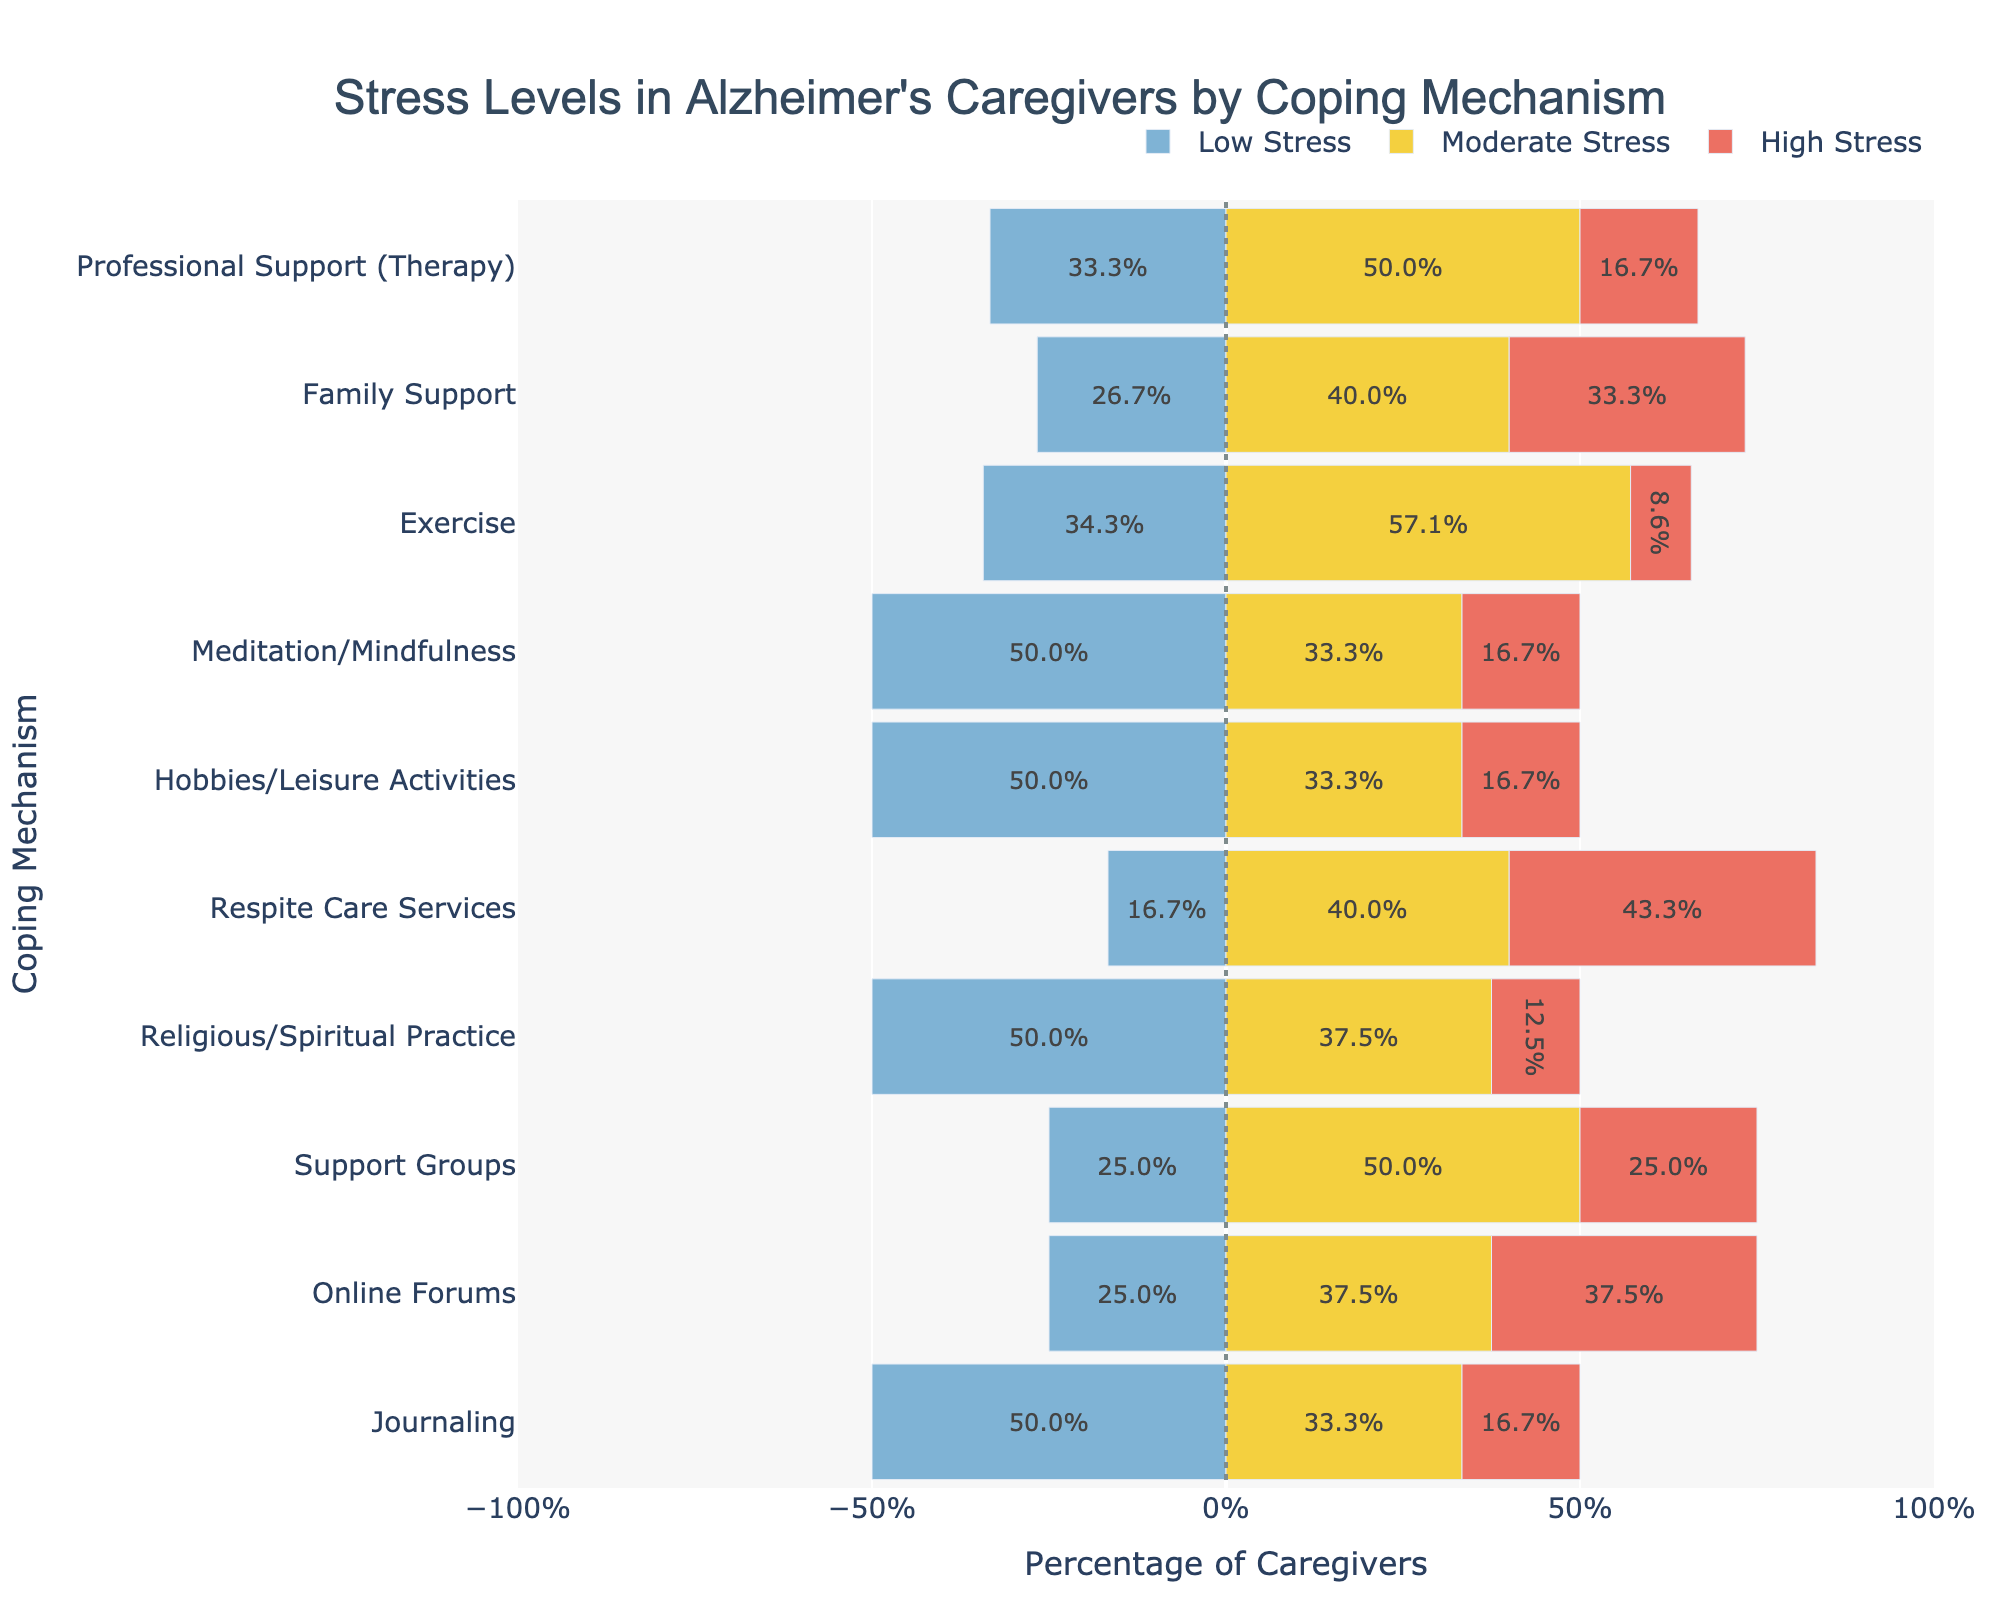How many caregivers reported low stress while using the exercise coping mechanism? Identify the "Exercise" coping mechanism along the y-axis. Locate the blue bar associated with it, representing low stress. The percentage value inside this bar indicates the number of caregivers who reported low stress, which is 12%.
Answer: 12 Which coping mechanism shows the highest percentage of caregivers reporting high stress? Examine the red bars for each coping mechanism. Identify the one with the highest value. "Online Forums" has the largest red bar with 15% of caregivers reporting high stress.
Answer: Online Forums Are there more caregivers reporting moderate stress or high stress while using family support as a coping mechanism? Locate the "Family Support" coping mechanism and compare the lengths of the yellow and red bars. The yellow bar (moderate stress) is 12%, and the red bar (high stress) is 10%. Therefore, more caregivers reported moderate stress.
Answer: Moderate stress What is the combined percentage of caregivers reporting low stress for professional support and family support? Find the blue bars for "Professional Support (Therapy)" (10%) and "Family Support" (8%). Add these percentages together: 10% + 8% = 18%.
Answer: 18% Which coping mechanism has the most balanced distribution of stress levels? Look for a coping mechanism where the blue, yellow, and red bars are similar in length. "Journaling" shows a distribution of 15% low, 10% moderate, and 5% high, making it relatively balanced.
Answer: Journaling Is the proportion of caregivers experiencing low stress higher for religious/spiritual practice or for hobbies/leisure activities? Compare the blue bars for "Religious/Spiritual Practice" (20%) and "Hobbies/Leisure Activities" (18%). The proportion is higher for "Religious/Spiritual Practice."
Answer: Religious/Spiritual Practice What is the difference in percentage points between high stress and low stress for caregivers using respite care services? For "Respite Care Services," identify the percentages for high stress (red bar, 13%) and low stress (blue bar, 5%). Subtract the low stress percentage from the high stress percentage: 13% - 5% = 8%.
Answer: 8 Among all coping mechanisms, which has the highest percentage of caregivers reporting low stress and which has the highest for moderate stress? Review the blue bars to find the highest percentage for low stress, which is "Religious/Spiritual Practice" at 20%. For moderate stress, examine the yellow bars; "Support Groups" has the highest percentage at 20%.
Answer: Religious/Spiritual Practice (low stress), Support Groups (moderate stress) Which coping mechanism has a high percentage of high stress but low percentage of low stress? Identify the red bars with high percentages and check the corresponding blue bars to ensure they have low values. "Respite Care Services" has a high stress percentage of 13% and a low stress percentage of 5%.
Answer: Respite Care Services 